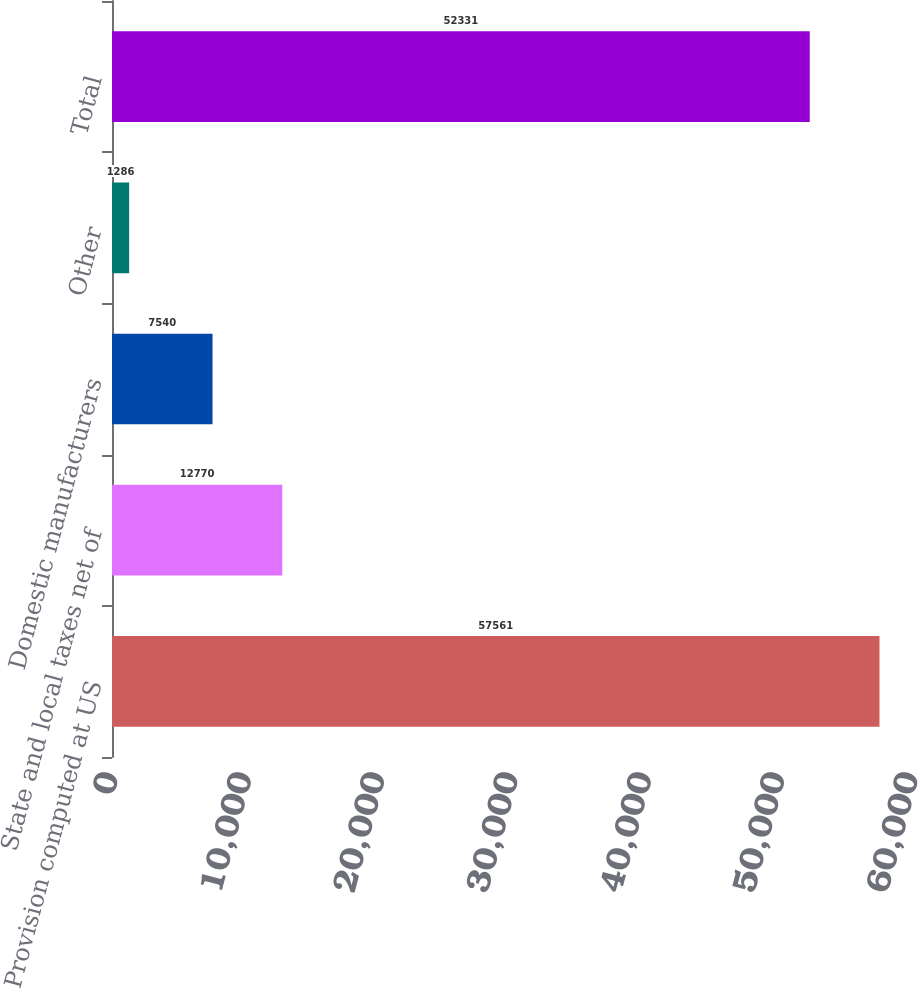Convert chart to OTSL. <chart><loc_0><loc_0><loc_500><loc_500><bar_chart><fcel>Provision computed at US<fcel>State and local taxes net of<fcel>Domestic manufacturers<fcel>Other<fcel>Total<nl><fcel>57561<fcel>12770<fcel>7540<fcel>1286<fcel>52331<nl></chart> 